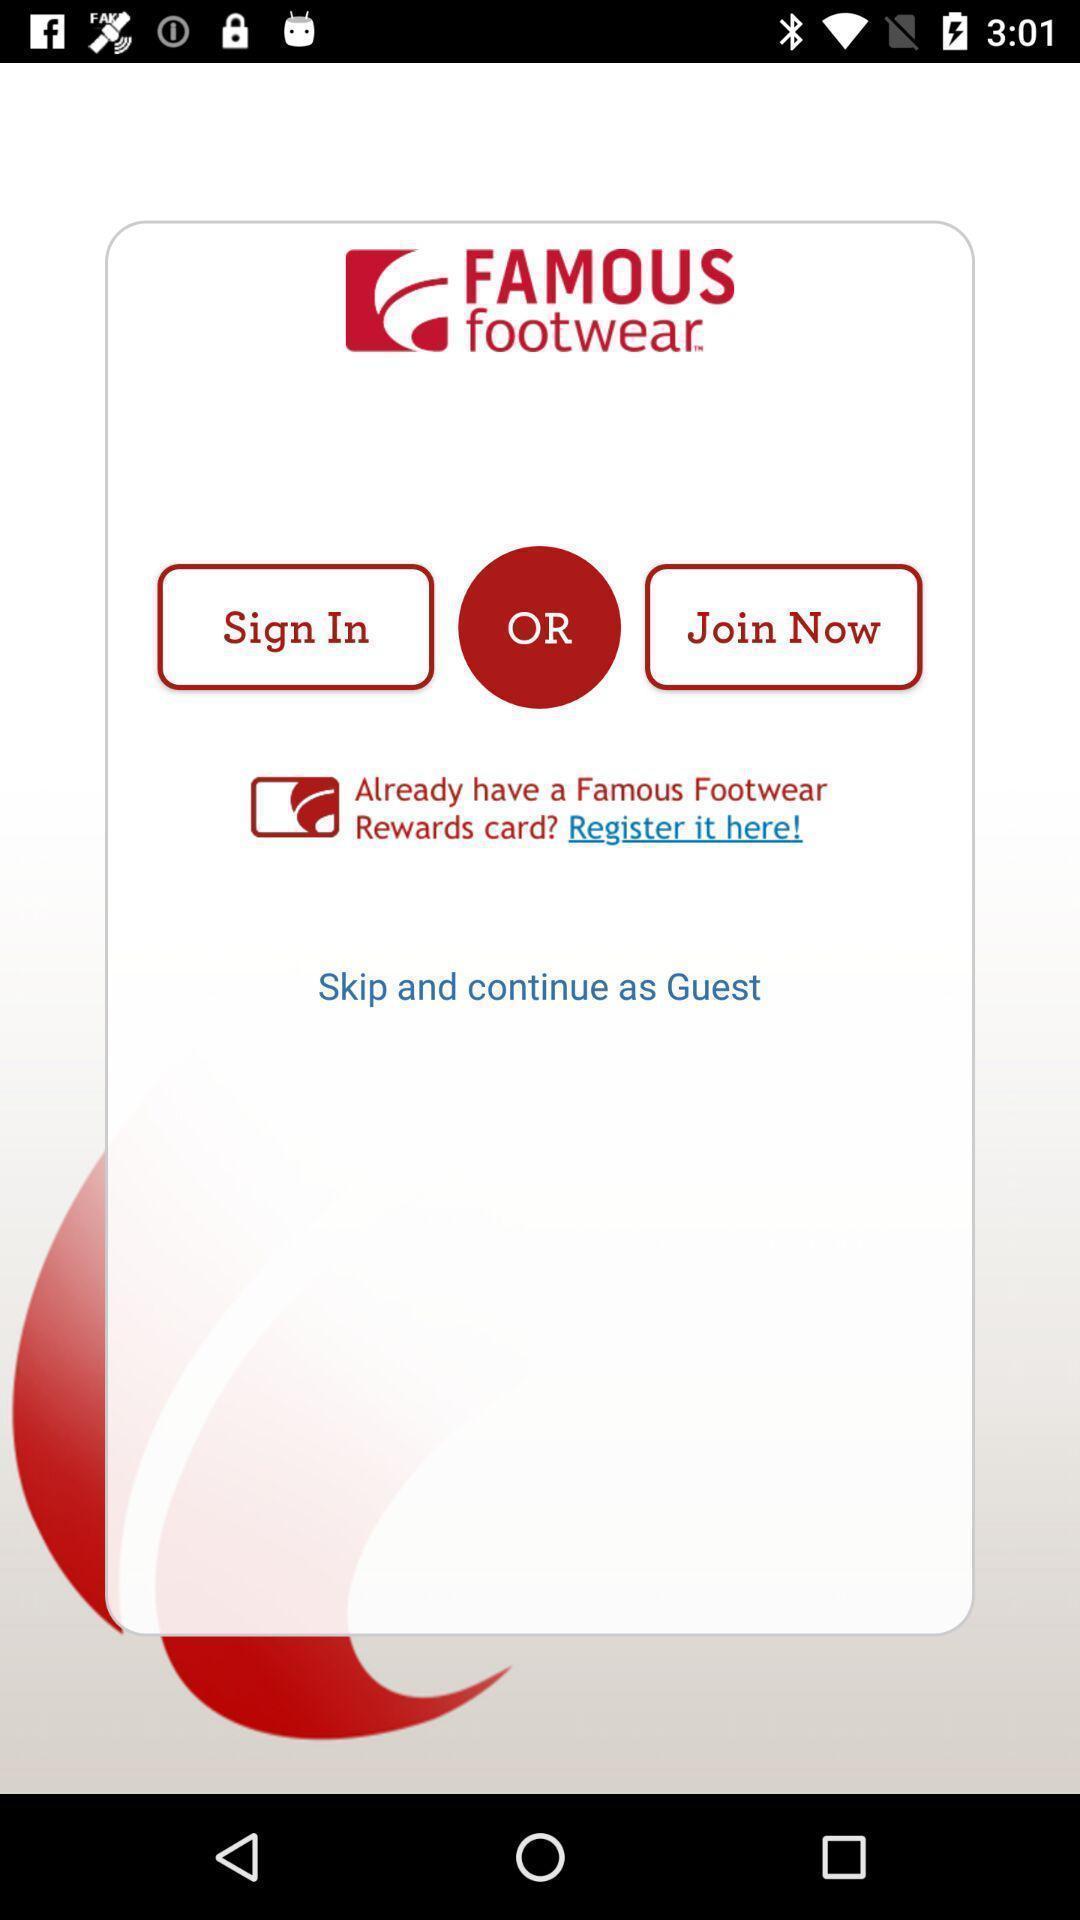Describe this image in words. Welcome page for a footwear app. 